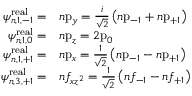<formula> <loc_0><loc_0><loc_500><loc_500>{ \begin{array} { r l } { \psi _ { n , 1 , - 1 } ^ { r e a l } = } & { n { p } _ { y } = { \frac { i } { \sqrt { 2 } } } \left ( n { p } _ { - 1 } + n { p } _ { + 1 } \right ) } \\ { \psi _ { n , 1 , 0 } ^ { r e a l } = } & { n { p } _ { z } = 2 { p } _ { 0 } } \\ { \psi _ { n , 1 , + 1 } ^ { r e a l } = } & { n { p } _ { x } = { \frac { 1 } { \sqrt { 2 } } } \left ( n { p } _ { - 1 } - n { p } _ { + 1 } \right ) } \\ { \psi _ { n , 3 , + 1 } ^ { r e a l } = } & { n f _ { x z ^ { 2 } } = { \frac { 1 } { \sqrt { 2 } } } \left ( n f _ { - 1 } - n f _ { + 1 } \right ) } \end{array} }</formula> 